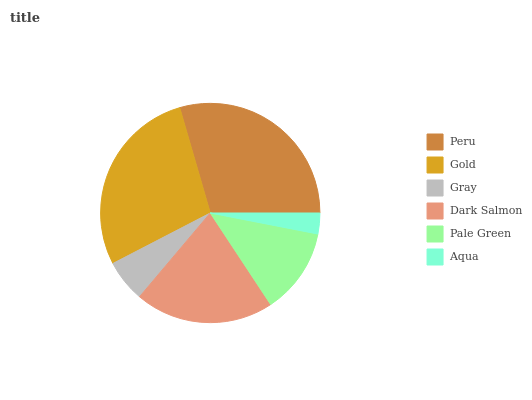Is Aqua the minimum?
Answer yes or no. Yes. Is Peru the maximum?
Answer yes or no. Yes. Is Gold the minimum?
Answer yes or no. No. Is Gold the maximum?
Answer yes or no. No. Is Peru greater than Gold?
Answer yes or no. Yes. Is Gold less than Peru?
Answer yes or no. Yes. Is Gold greater than Peru?
Answer yes or no. No. Is Peru less than Gold?
Answer yes or no. No. Is Dark Salmon the high median?
Answer yes or no. Yes. Is Pale Green the low median?
Answer yes or no. Yes. Is Aqua the high median?
Answer yes or no. No. Is Gray the low median?
Answer yes or no. No. 